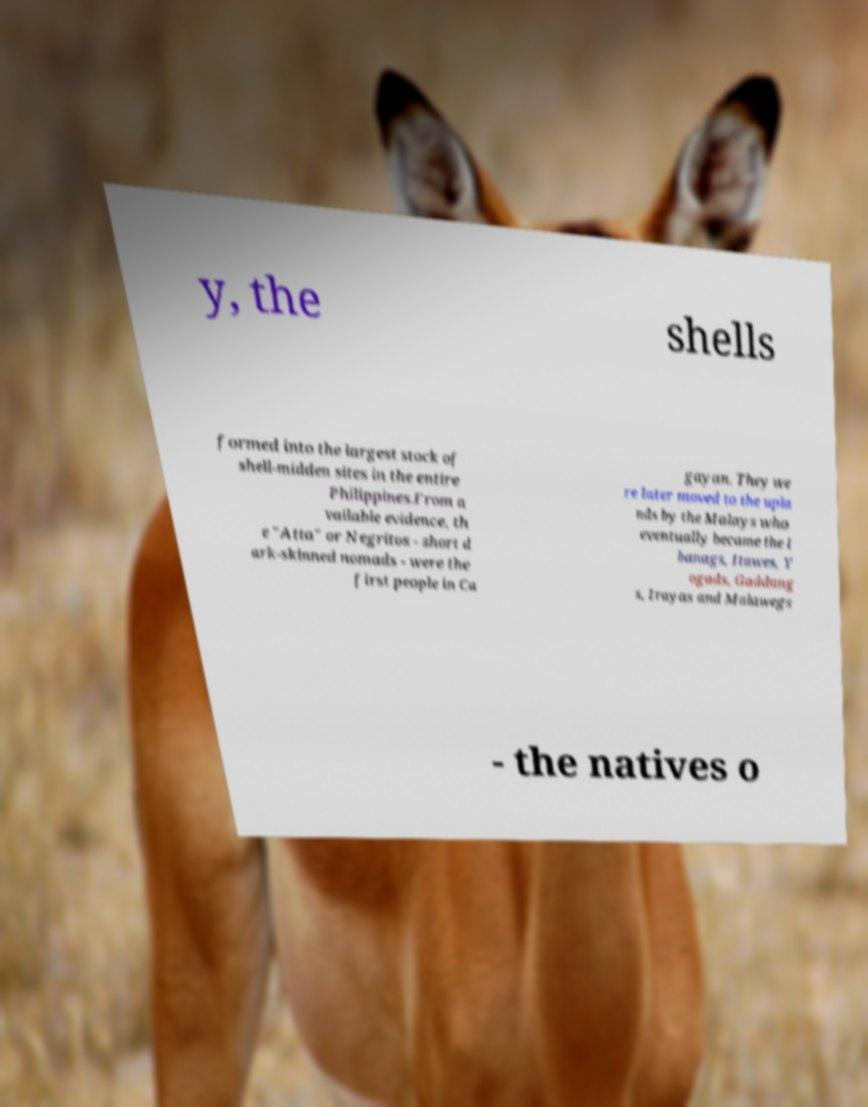There's text embedded in this image that I need extracted. Can you transcribe it verbatim? y, the shells formed into the largest stock of shell-midden sites in the entire Philippines.From a vailable evidence, th e "Atta" or Negritos - short d ark-skinned nomads - were the first people in Ca gayan. They we re later moved to the upla nds by the Malays who eventually became the I banags, Itawes, Y ogads, Gaddang s, Irayas and Malawegs - the natives o 